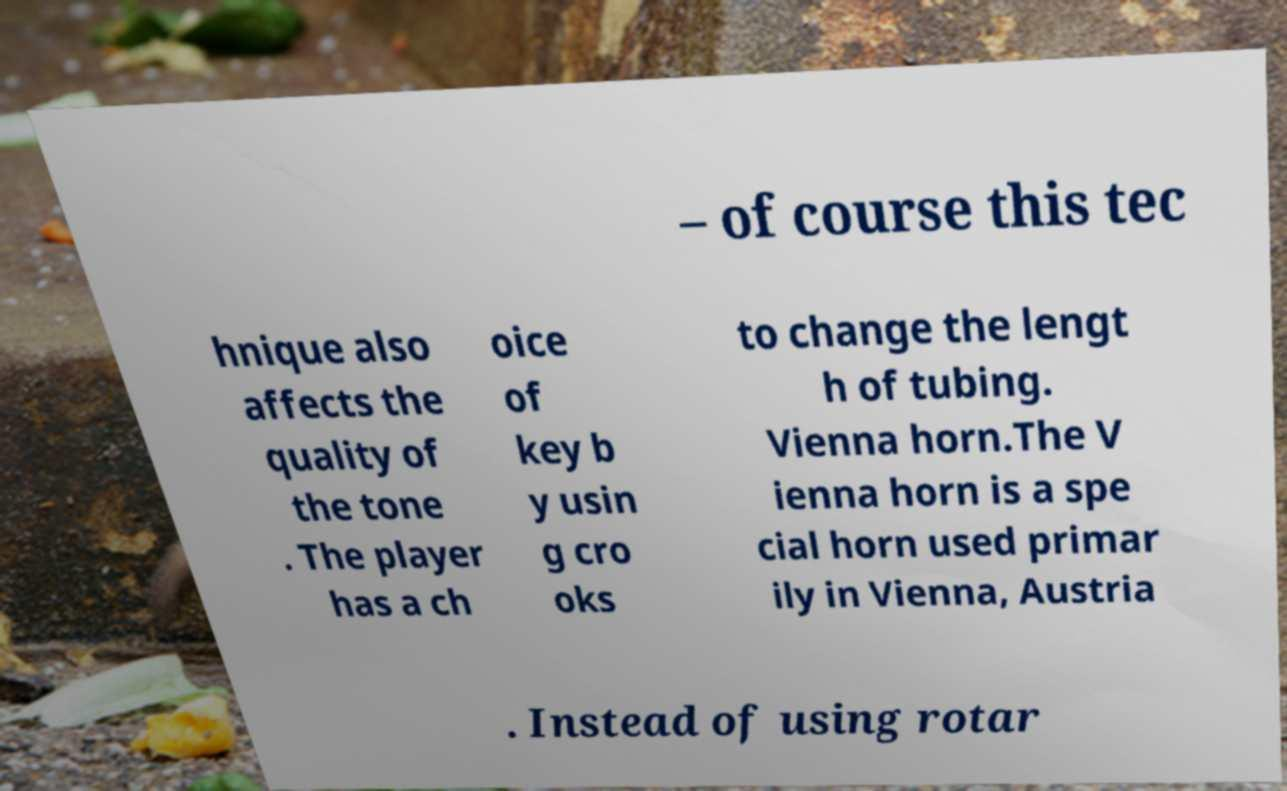There's text embedded in this image that I need extracted. Can you transcribe it verbatim? – of course this tec hnique also affects the quality of the tone . The player has a ch oice of key b y usin g cro oks to change the lengt h of tubing. Vienna horn.The V ienna horn is a spe cial horn used primar ily in Vienna, Austria . Instead of using rotar 